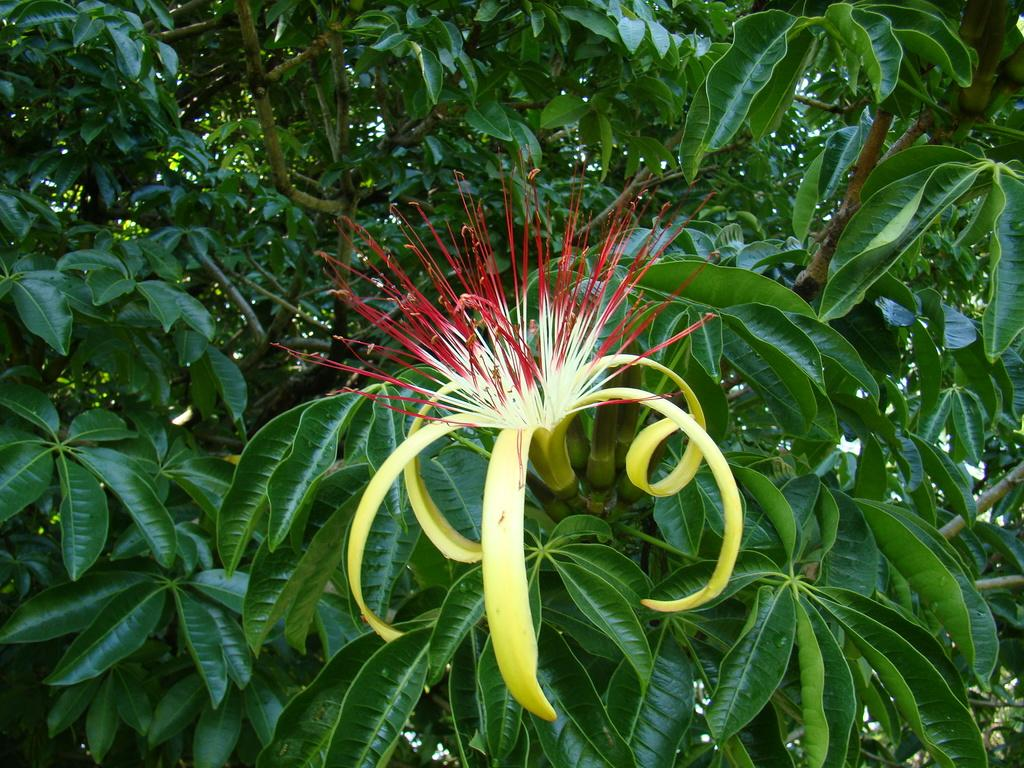What is the main subject in the middle of the image? There is a flower in the middle of the image. What type of vegetation can be seen in the image? Tree leaves are visible in the image. How many dinosaurs can be seen in the image? There are no dinosaurs present in the image. What type of machine is visible in the image? There is no machine present in the image. 